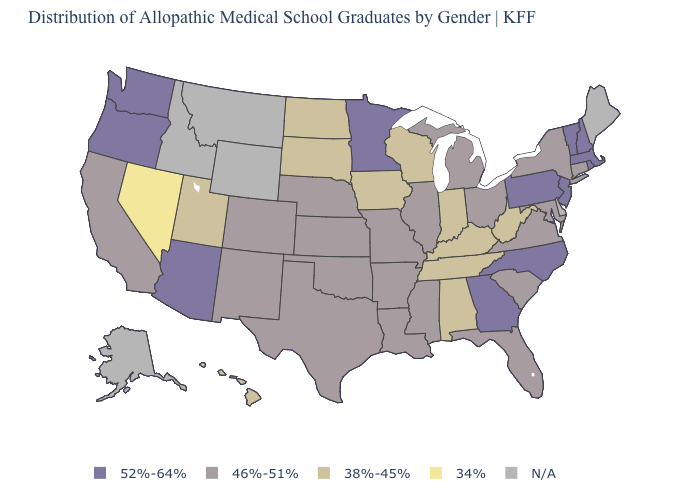Name the states that have a value in the range 46%-51%?
Answer briefly. Arkansas, California, Colorado, Connecticut, Florida, Illinois, Kansas, Louisiana, Maryland, Michigan, Mississippi, Missouri, Nebraska, New Mexico, New York, Ohio, Oklahoma, South Carolina, Texas, Virginia. What is the value of Maine?
Be succinct. N/A. What is the value of Alaska?
Write a very short answer. N/A. What is the highest value in the USA?
Answer briefly. 52%-64%. What is the value of New York?
Short answer required. 46%-51%. Name the states that have a value in the range 46%-51%?
Be succinct. Arkansas, California, Colorado, Connecticut, Florida, Illinois, Kansas, Louisiana, Maryland, Michigan, Mississippi, Missouri, Nebraska, New Mexico, New York, Ohio, Oklahoma, South Carolina, Texas, Virginia. What is the highest value in states that border Oregon?
Answer briefly. 52%-64%. What is the highest value in the USA?
Write a very short answer. 52%-64%. Does Minnesota have the highest value in the USA?
Keep it brief. Yes. What is the value of Arizona?
Be succinct. 52%-64%. What is the lowest value in states that border New Jersey?
Be succinct. 46%-51%. Name the states that have a value in the range 34%?
Write a very short answer. Nevada. Name the states that have a value in the range 38%-45%?
Give a very brief answer. Alabama, Hawaii, Indiana, Iowa, Kentucky, North Dakota, South Dakota, Tennessee, Utah, West Virginia, Wisconsin. What is the highest value in the MidWest ?
Short answer required. 52%-64%. 